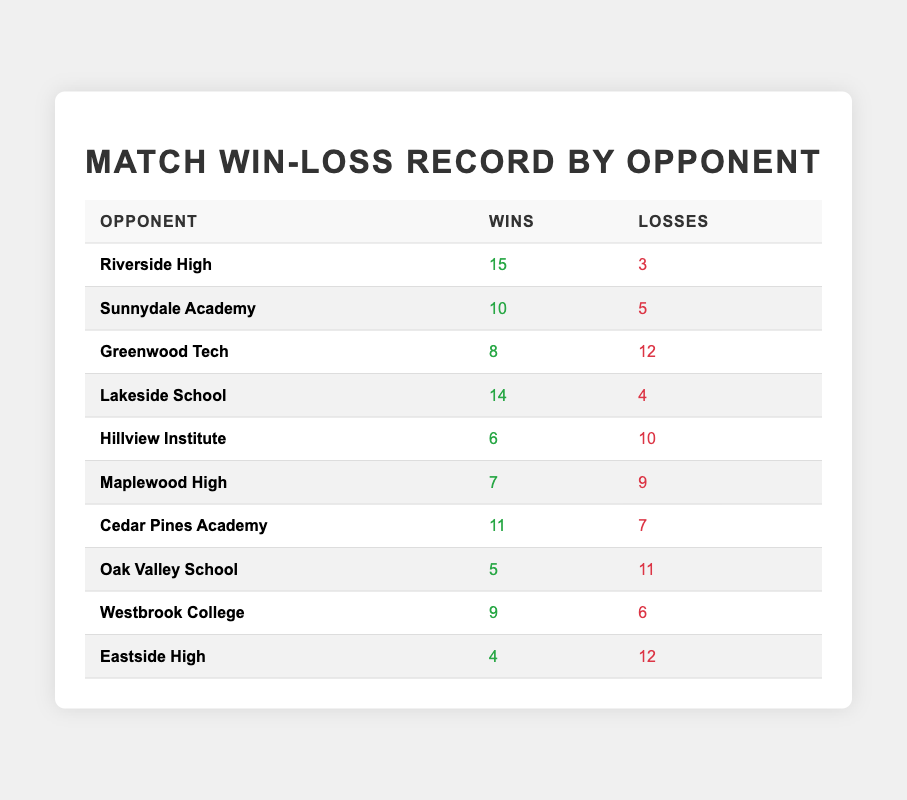What is the total number of wins recorded against Riverside High? The table indicates that the wins against Riverside High are specifically listed as 15.
Answer: 15 How many losses did the team suffer against Eastside High? The table shows that the team lost 12 matches against Eastside High.
Answer: 12 Who is the opponent with the highest number of wins? Reviewing the table, Riverside High has the highest wins at 15.
Answer: Riverside High How many opponents recorded more wins than losses? The table lists the following opponents with more wins than losses: Riverside High, Sunnydale Academy, Lakeside School, and Cedar Pines Academy. That totals to 4 opponents.
Answer: 4 What is the total number of matches played against Greenwood Tech? Calculation involves summing wins and losses: 8 wins + 12 losses = 20 matches.
Answer: 20 Which opponent has the lowest win total? Looking at the table, Oak Valley School has the lowest wins at 5.
Answer: Oak Valley School How does the win-loss ratio against Lakeside School compare to that against Maplewood High? Lakeside School has a win-loss ratio of 14:4 (3.5), while Maplewood High has a ratio of 7:9 (0.78). Comparing, Lakeside School has a better win-loss ratio.
Answer: Lakeside School has a better ratio How many matches did the team win against opponents with at least 10 wins? The opponents with at least 10 wins are Riverside High (15), Sunnydale Academy (10), and Cedar Pines Academy (11). The total wins against these teams is 15 + 10 + 11 = 36.
Answer: 36 Is the number of wins against Westbrook College greater than the total losses against Hillview Institute? Wins against Westbrook College are 9, while losses against Hillview Institute total 10. Therefore, 9 is not greater than 10.
Answer: No What is the difference in total wins and losses across all opponents? The total wins are (15 + 10 + 8 + 14 + 6 + 7 + 11 + 5 + 9 + 4) = 89 and losses are (3 + 5 + 12 + 4 + 10 + 9 + 7 + 11 + 6 + 12) = 89. The difference is 89 - 89 = 0.
Answer: 0 